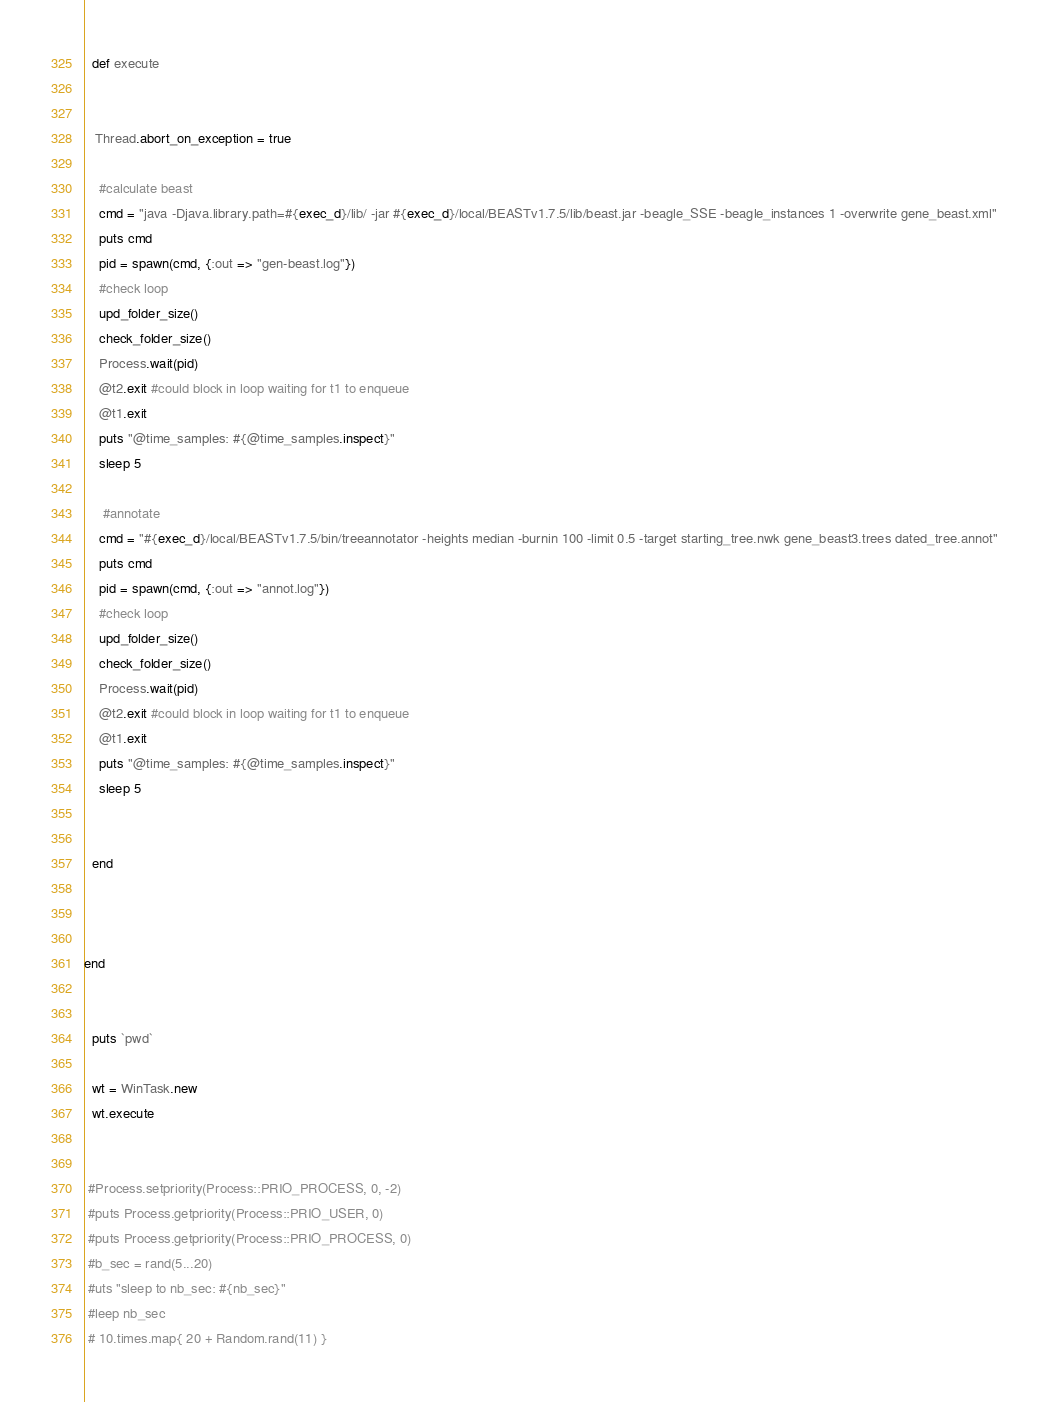Convert code to text. <code><loc_0><loc_0><loc_500><loc_500><_Ruby_>
  def execute

   
   Thread.abort_on_exception = true

    #calculate beast
    cmd = "java -Djava.library.path=#{exec_d}/lib/ -jar #{exec_d}/local/BEASTv1.7.5/lib/beast.jar -beagle_SSE -beagle_instances 1 -overwrite gene_beast.xml"
    puts cmd
    pid = spawn(cmd, {:out => "gen-beast.log"})
    #check loop
    upd_folder_size() 
    check_folder_size()
    Process.wait(pid)
    @t2.exit #could block in loop waiting for t1 to enqueue
    @t1.exit
    puts "@time_samples: #{@time_samples.inspect}"
    sleep 5 

     #annotate
    cmd = "#{exec_d}/local/BEASTv1.7.5/bin/treeannotator -heights median -burnin 100 -limit 0.5 -target starting_tree.nwk gene_beast3.trees dated_tree.annot"
    puts cmd
    pid = spawn(cmd, {:out => "annot.log"})
    #check loop
    upd_folder_size()
    check_folder_size()
    Process.wait(pid)
    @t2.exit #could block in loop waiting for t1 to enqueue
    @t1.exit
    puts "@time_samples: #{@time_samples.inspect}"
    sleep 5
   

  end
  


end


  puts `pwd`
 
  wt = WinTask.new
  wt.execute

  
 #Process.setpriority(Process::PRIO_PROCESS, 0, -2)
 #puts Process.getpriority(Process::PRIO_USER, 0)   
 #puts Process.getpriority(Process::PRIO_PROCESS, 0) 
 #b_sec = rand(5...20)
 #uts "sleep to nb_sec: #{nb_sec}"
 #leep nb_sec
 # 10.times.map{ 20 + Random.rand(11) }
</code> 